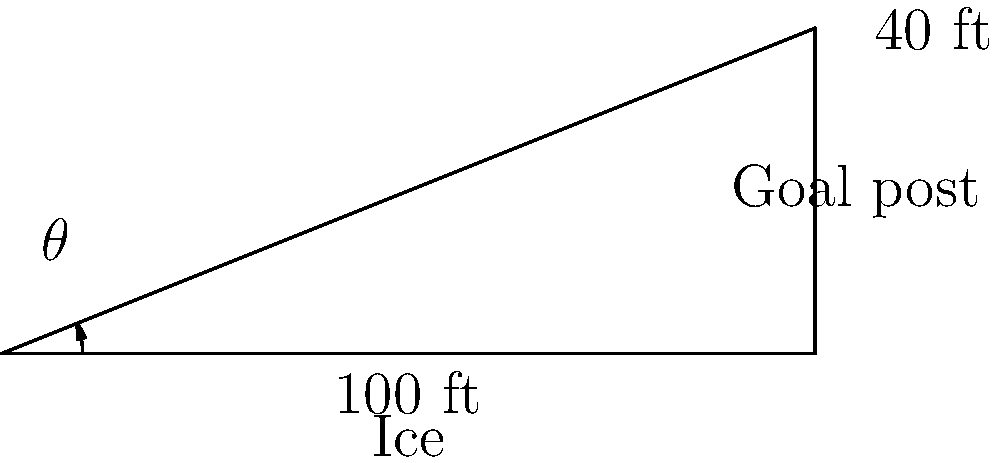During a crucial moment in the championship game, you're preparing to take a slapshot from the blue line. The goal post is 100 feet away and 40 feet across from your position. What is the angle $\theta$ (in degrees) at which you need to aim your slapshot for the most direct path to the goal post? To solve this problem, we'll use the arctangent function, which is the inverse of the tangent function. Here's how we can approach it step-by-step:

1) First, let's identify the triangle formed by your position, the goal post, and the point directly across from you on the goal line.

2) We know the opposite side (across from the angle we're looking for) is 40 feet, and the adjacent side is 100 feet.

3) The tangent of an angle is defined as the opposite side divided by the adjacent side. In this case:

   $\tan(\theta) = \frac{\text{opposite}}{\text{adjacent}} = \frac{40}{100} = 0.4$

4) To find $\theta$, we need to use the inverse tangent function (arctangent or $\tan^{-1}$):

   $\theta = \tan^{-1}(0.4)$

5) Using a calculator or mathematical software to compute this:

   $\theta \approx 21.8014867^\circ$

6) Rounding to one decimal place for practical use on the ice:

   $\theta \approx 21.8^\circ$

Therefore, you should aim your slapshot at approximately 21.8 degrees for the most direct path to the goal post.
Answer: $21.8^\circ$ 